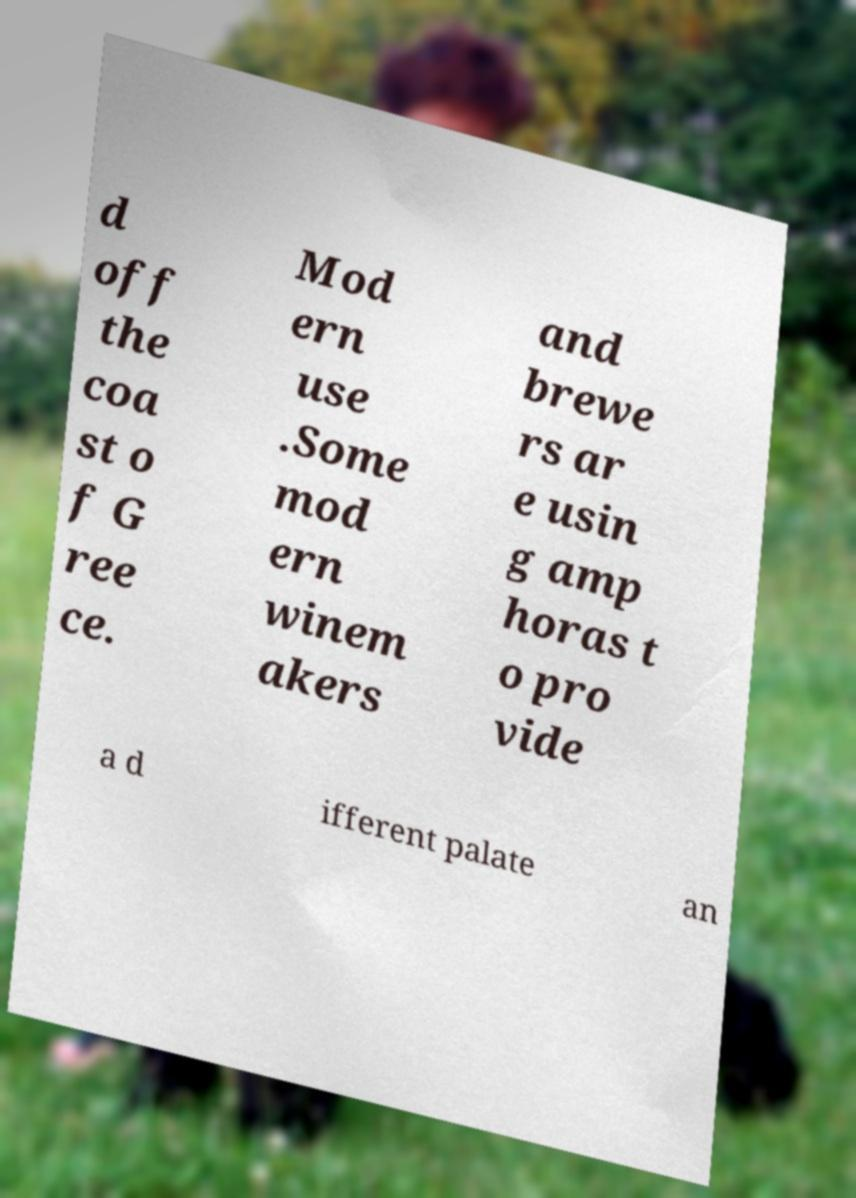Could you extract and type out the text from this image? d off the coa st o f G ree ce. Mod ern use .Some mod ern winem akers and brewe rs ar e usin g amp horas t o pro vide a d ifferent palate an 